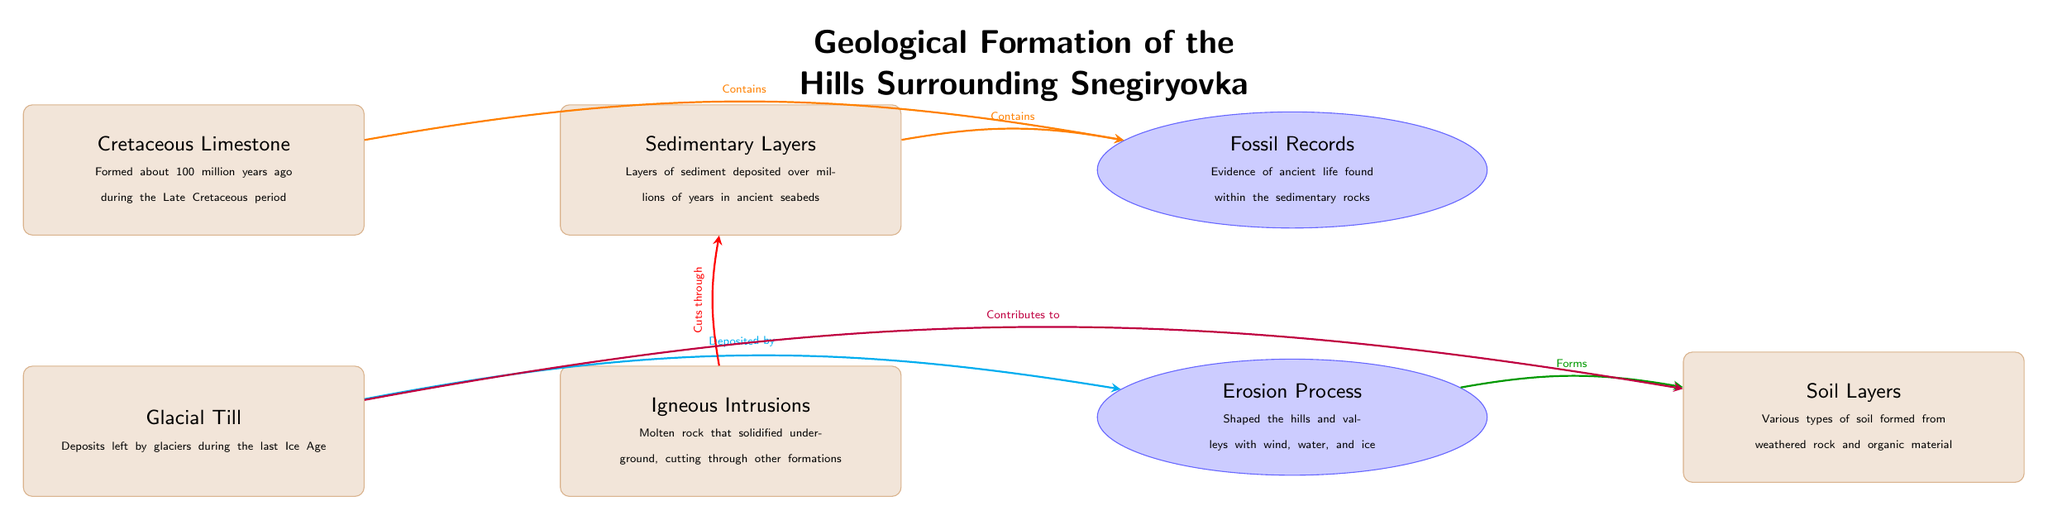What geological formation is labeled as the oldest in the diagram? The oldest geological formation mentioned in the diagram is the Cretaceous Limestone, which formed about 100 million years ago during the Late Cretaceous period.
Answer: Cretaceous Limestone How many geology nodes are present in the diagram? The diagram includes four geology nodes: Cretaceous Limestone, Glacial Till, Sedimentary Layers, and Igneous Intrusions, adding up to a total of four.
Answer: 4 What processes are connected to the Glacial Till? The Glacial Till is connected to two processes: it contributes to soil and it is deposited by the erosion process.
Answer: Contributes to soil, deposited by erosion Which geological formation is known to cut through another formation? The Igneous Intrusions cut through the Sedimentary Layers, indicating a relationship where the igneous rock invades other layers.
Answer: Igneous Intrusions What is the relationship between Cretaceous Limestone and Fossil Records? Cretaceous Limestone contains fossil records, indicating that ancient life has been preserved within this geological layer.
Answer: Contains How do erosion processes impact the soil? The erosion process forms soil by breaking down rock and organic material. The diagram shows a direct relationship where erosion shapes the landscape and contributes to soil formation.
Answer: Forms What does Sedimentary Layers primarily contain? Sedimentary Layers primarily contain fossil records, which serve as evidence of ancient life found within sedimentary rocks.
Answer: Fossil Records Which layer was deposited during the last Ice Age? The Glacial Till was specifically deposited by glaciers during the last Ice Age, highlighting its relation to glacial activity.
Answer: Glacial Till What is the function of the Fossil Records node in relation to sedimentary formations? The Fossil Records node represents evidence of ancient life found within both the Cretaceous Limestone and Sedimentary Layers, showing that these geological formations are significant for paleontological studies.
Answer: Evidence of ancient life 